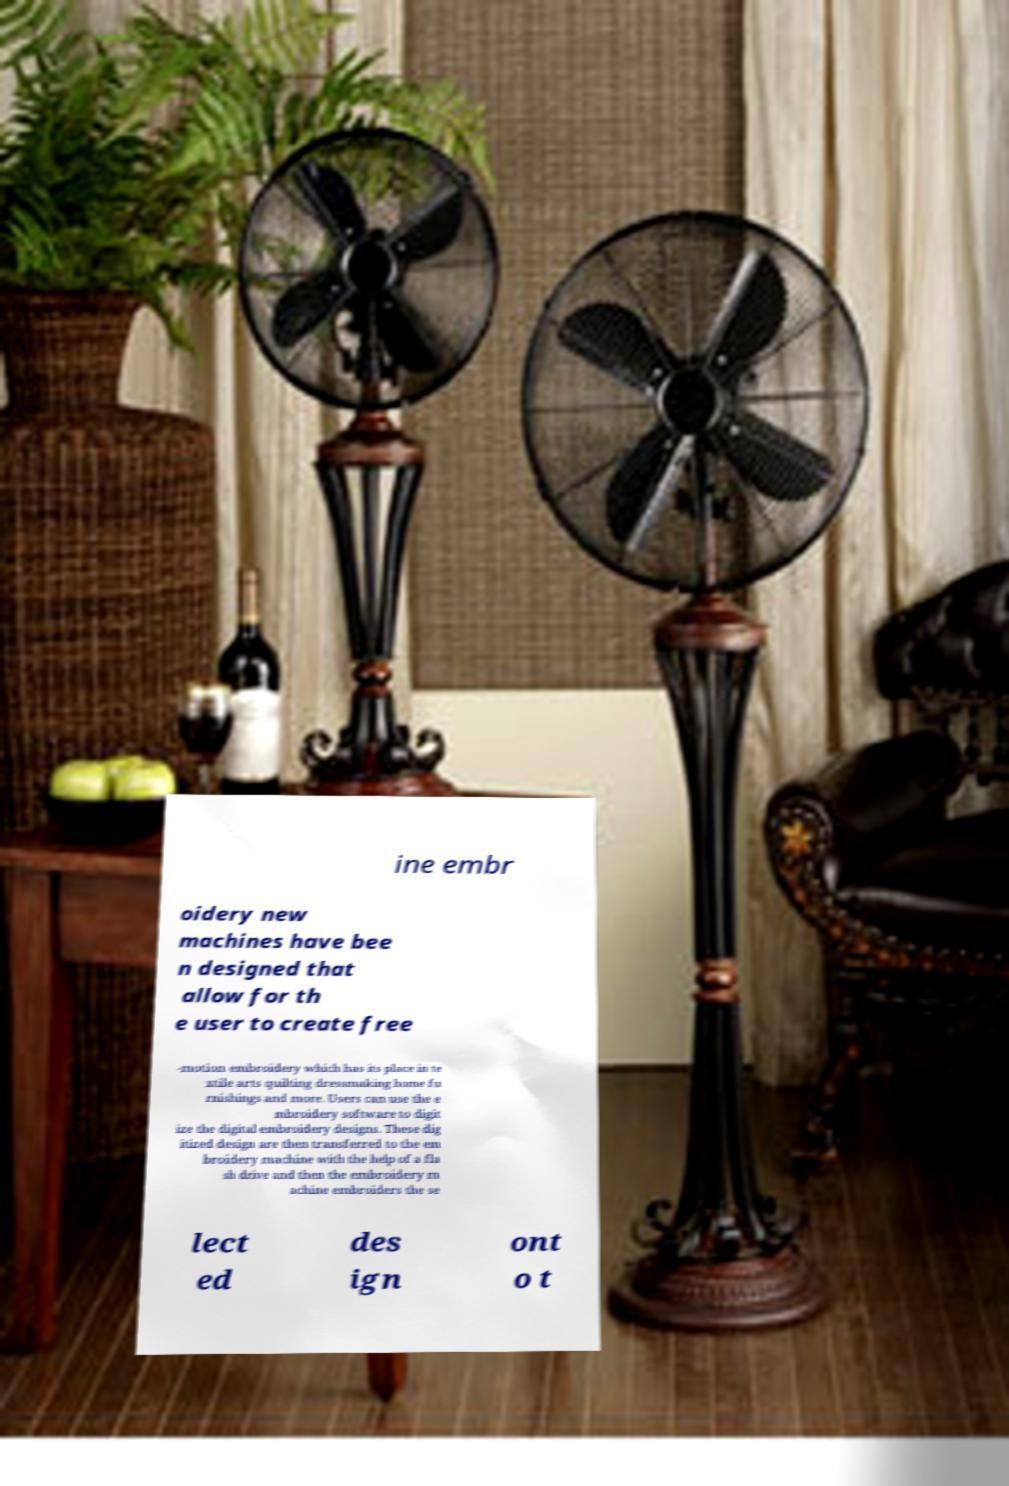Can you accurately transcribe the text from the provided image for me? ine embr oidery new machines have bee n designed that allow for th e user to create free -motion embroidery which has its place in te xtile arts quilting dressmaking home fu rnishings and more. Users can use the e mbroidery software to digit ize the digital embroidery designs. These dig itized design are then transferred to the em broidery machine with the help of a fla sh drive and then the embroidery m achine embroiders the se lect ed des ign ont o t 